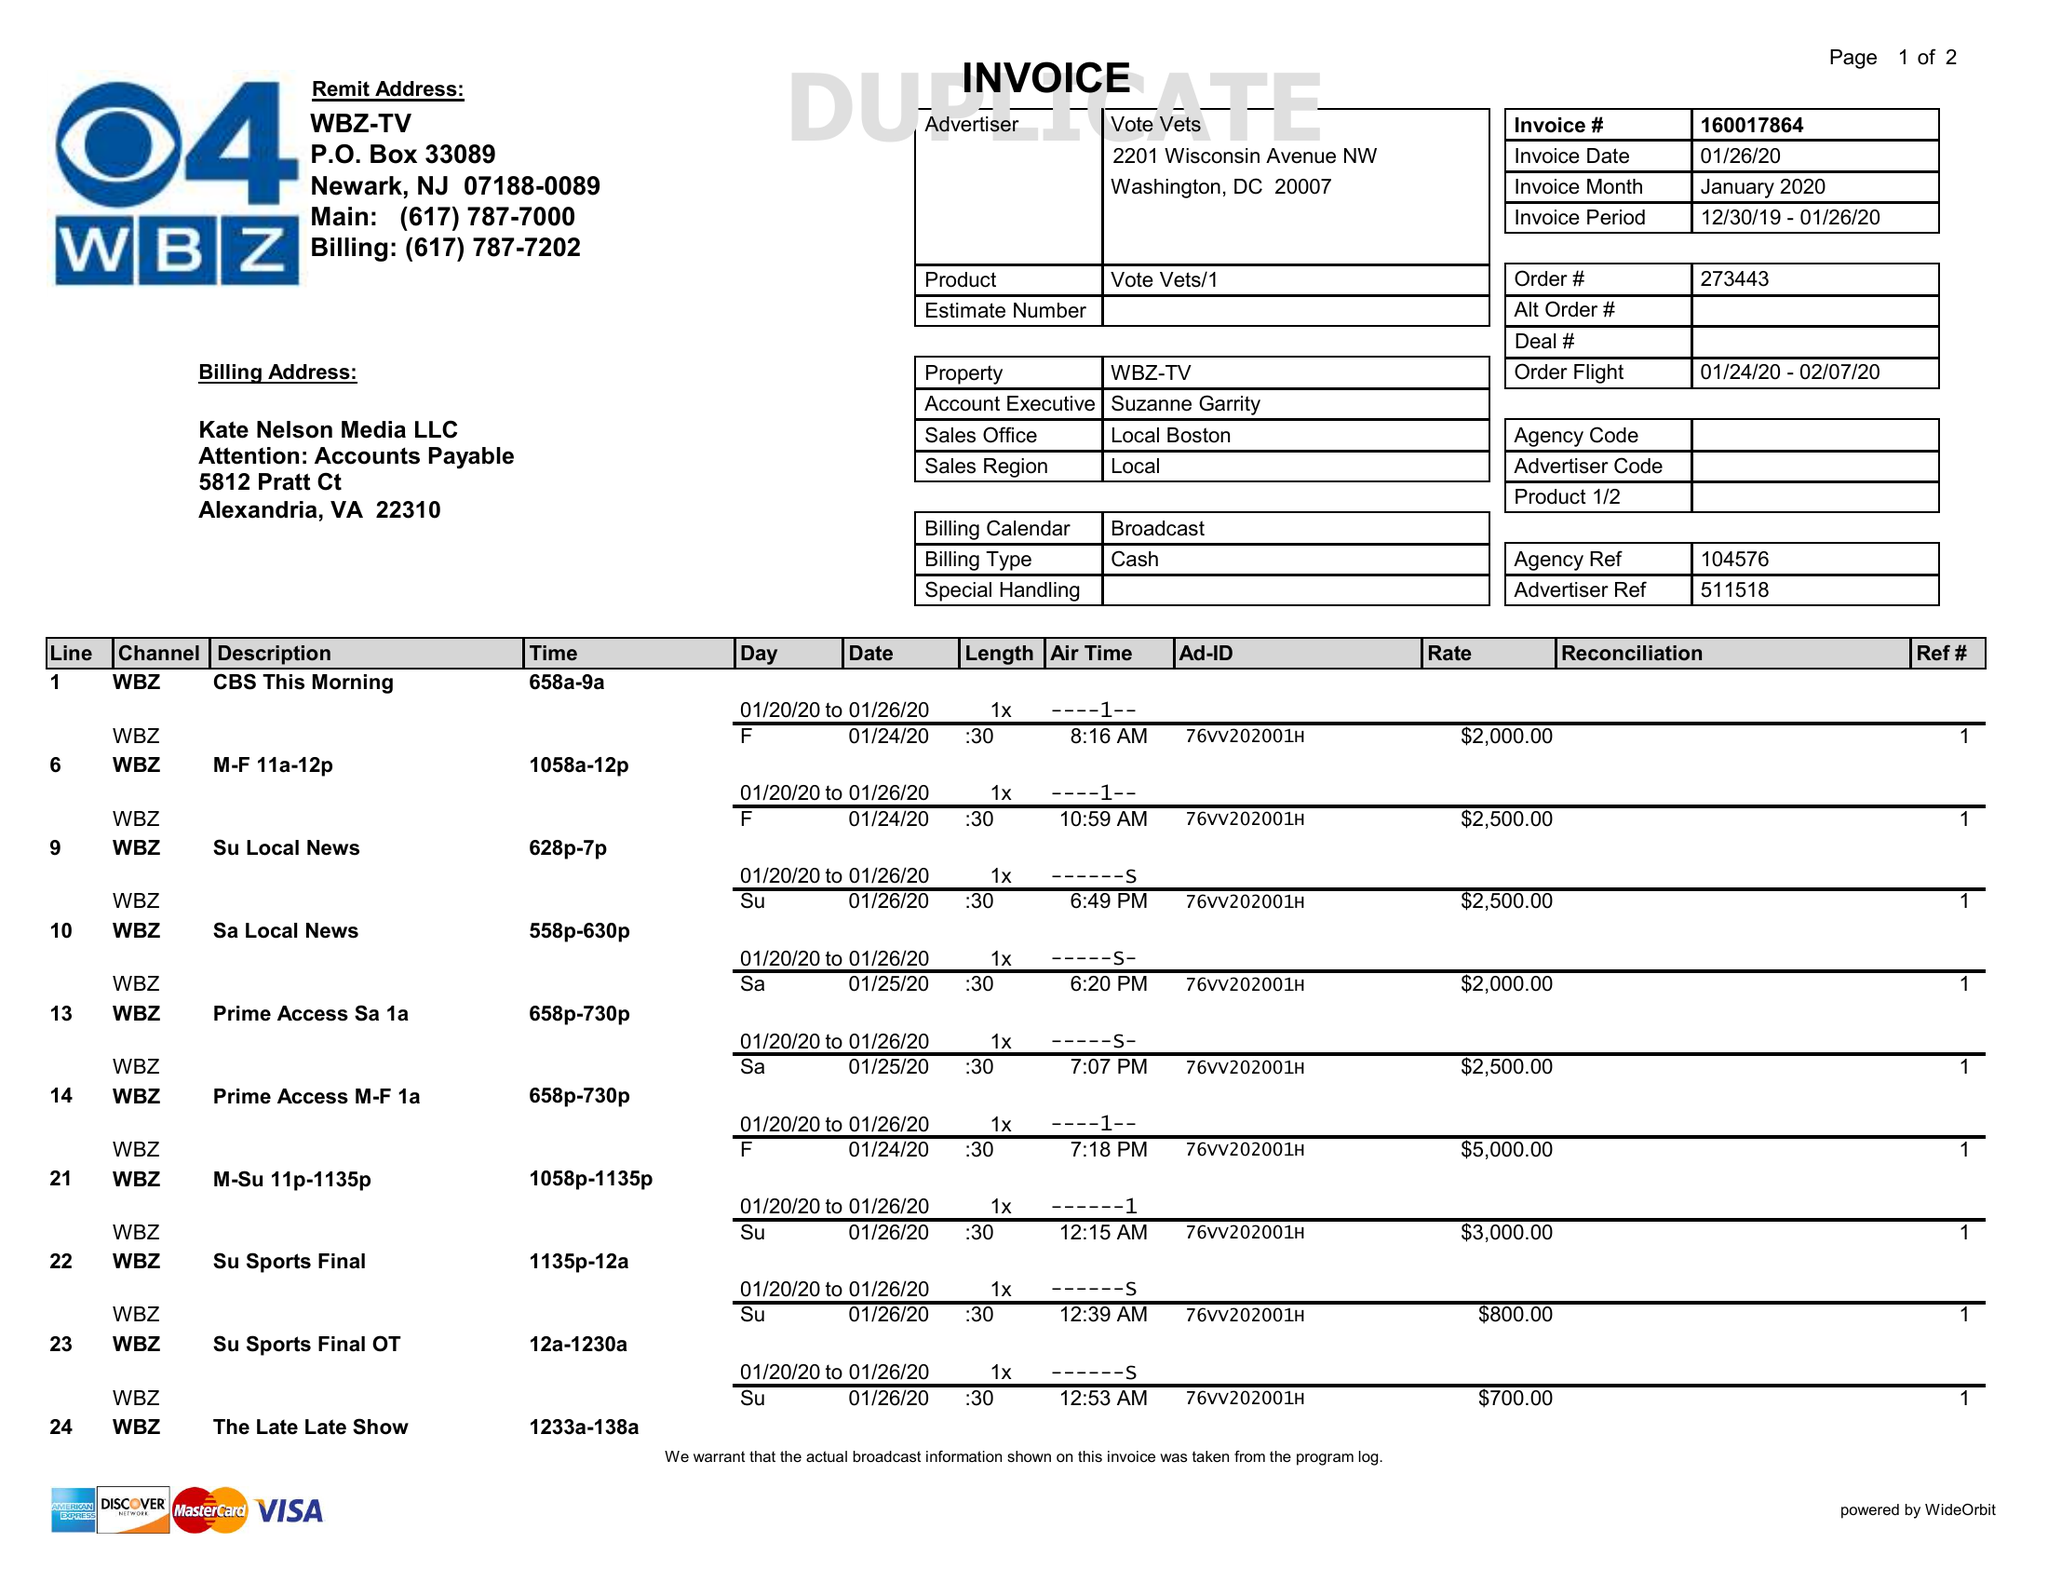What is the value for the gross_amount?
Answer the question using a single word or phrase. 25800.00 